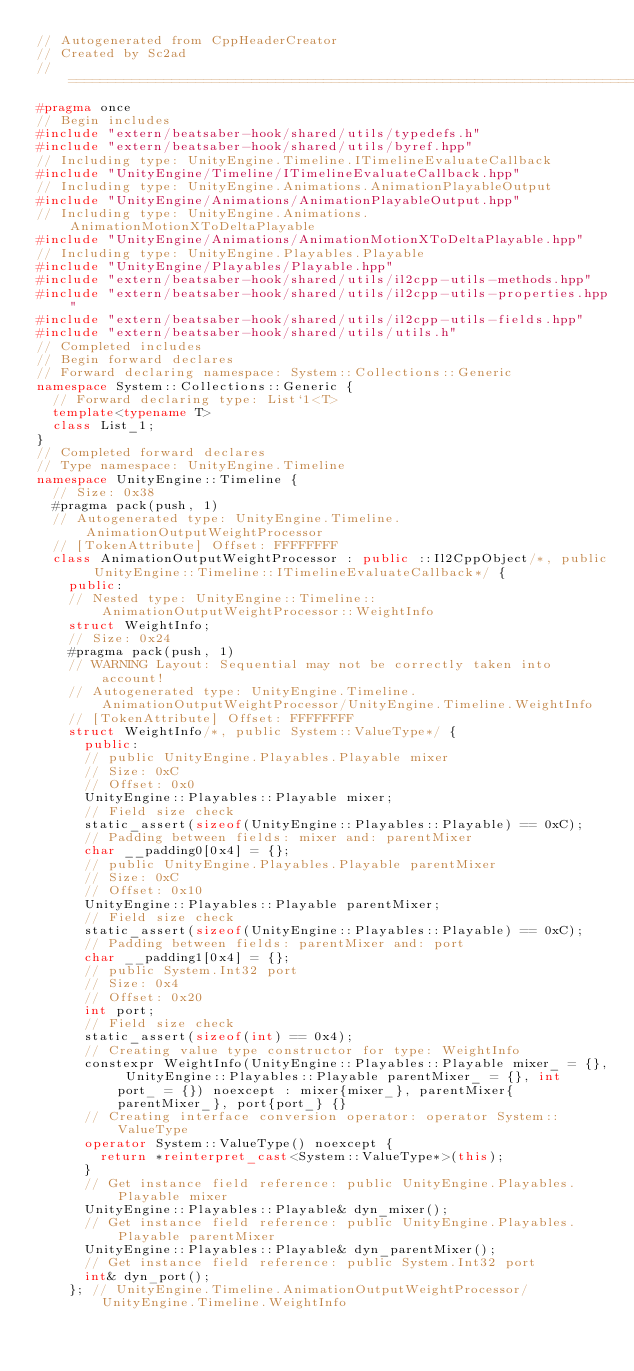<code> <loc_0><loc_0><loc_500><loc_500><_C++_>// Autogenerated from CppHeaderCreator
// Created by Sc2ad
// =========================================================================
#pragma once
// Begin includes
#include "extern/beatsaber-hook/shared/utils/typedefs.h"
#include "extern/beatsaber-hook/shared/utils/byref.hpp"
// Including type: UnityEngine.Timeline.ITimelineEvaluateCallback
#include "UnityEngine/Timeline/ITimelineEvaluateCallback.hpp"
// Including type: UnityEngine.Animations.AnimationPlayableOutput
#include "UnityEngine/Animations/AnimationPlayableOutput.hpp"
// Including type: UnityEngine.Animations.AnimationMotionXToDeltaPlayable
#include "UnityEngine/Animations/AnimationMotionXToDeltaPlayable.hpp"
// Including type: UnityEngine.Playables.Playable
#include "UnityEngine/Playables/Playable.hpp"
#include "extern/beatsaber-hook/shared/utils/il2cpp-utils-methods.hpp"
#include "extern/beatsaber-hook/shared/utils/il2cpp-utils-properties.hpp"
#include "extern/beatsaber-hook/shared/utils/il2cpp-utils-fields.hpp"
#include "extern/beatsaber-hook/shared/utils/utils.h"
// Completed includes
// Begin forward declares
// Forward declaring namespace: System::Collections::Generic
namespace System::Collections::Generic {
  // Forward declaring type: List`1<T>
  template<typename T>
  class List_1;
}
// Completed forward declares
// Type namespace: UnityEngine.Timeline
namespace UnityEngine::Timeline {
  // Size: 0x38
  #pragma pack(push, 1)
  // Autogenerated type: UnityEngine.Timeline.AnimationOutputWeightProcessor
  // [TokenAttribute] Offset: FFFFFFFF
  class AnimationOutputWeightProcessor : public ::Il2CppObject/*, public UnityEngine::Timeline::ITimelineEvaluateCallback*/ {
    public:
    // Nested type: UnityEngine::Timeline::AnimationOutputWeightProcessor::WeightInfo
    struct WeightInfo;
    // Size: 0x24
    #pragma pack(push, 1)
    // WARNING Layout: Sequential may not be correctly taken into account!
    // Autogenerated type: UnityEngine.Timeline.AnimationOutputWeightProcessor/UnityEngine.Timeline.WeightInfo
    // [TokenAttribute] Offset: FFFFFFFF
    struct WeightInfo/*, public System::ValueType*/ {
      public:
      // public UnityEngine.Playables.Playable mixer
      // Size: 0xC
      // Offset: 0x0
      UnityEngine::Playables::Playable mixer;
      // Field size check
      static_assert(sizeof(UnityEngine::Playables::Playable) == 0xC);
      // Padding between fields: mixer and: parentMixer
      char __padding0[0x4] = {};
      // public UnityEngine.Playables.Playable parentMixer
      // Size: 0xC
      // Offset: 0x10
      UnityEngine::Playables::Playable parentMixer;
      // Field size check
      static_assert(sizeof(UnityEngine::Playables::Playable) == 0xC);
      // Padding between fields: parentMixer and: port
      char __padding1[0x4] = {};
      // public System.Int32 port
      // Size: 0x4
      // Offset: 0x20
      int port;
      // Field size check
      static_assert(sizeof(int) == 0x4);
      // Creating value type constructor for type: WeightInfo
      constexpr WeightInfo(UnityEngine::Playables::Playable mixer_ = {}, UnityEngine::Playables::Playable parentMixer_ = {}, int port_ = {}) noexcept : mixer{mixer_}, parentMixer{parentMixer_}, port{port_} {}
      // Creating interface conversion operator: operator System::ValueType
      operator System::ValueType() noexcept {
        return *reinterpret_cast<System::ValueType*>(this);
      }
      // Get instance field reference: public UnityEngine.Playables.Playable mixer
      UnityEngine::Playables::Playable& dyn_mixer();
      // Get instance field reference: public UnityEngine.Playables.Playable parentMixer
      UnityEngine::Playables::Playable& dyn_parentMixer();
      // Get instance field reference: public System.Int32 port
      int& dyn_port();
    }; // UnityEngine.Timeline.AnimationOutputWeightProcessor/UnityEngine.Timeline.WeightInfo</code> 